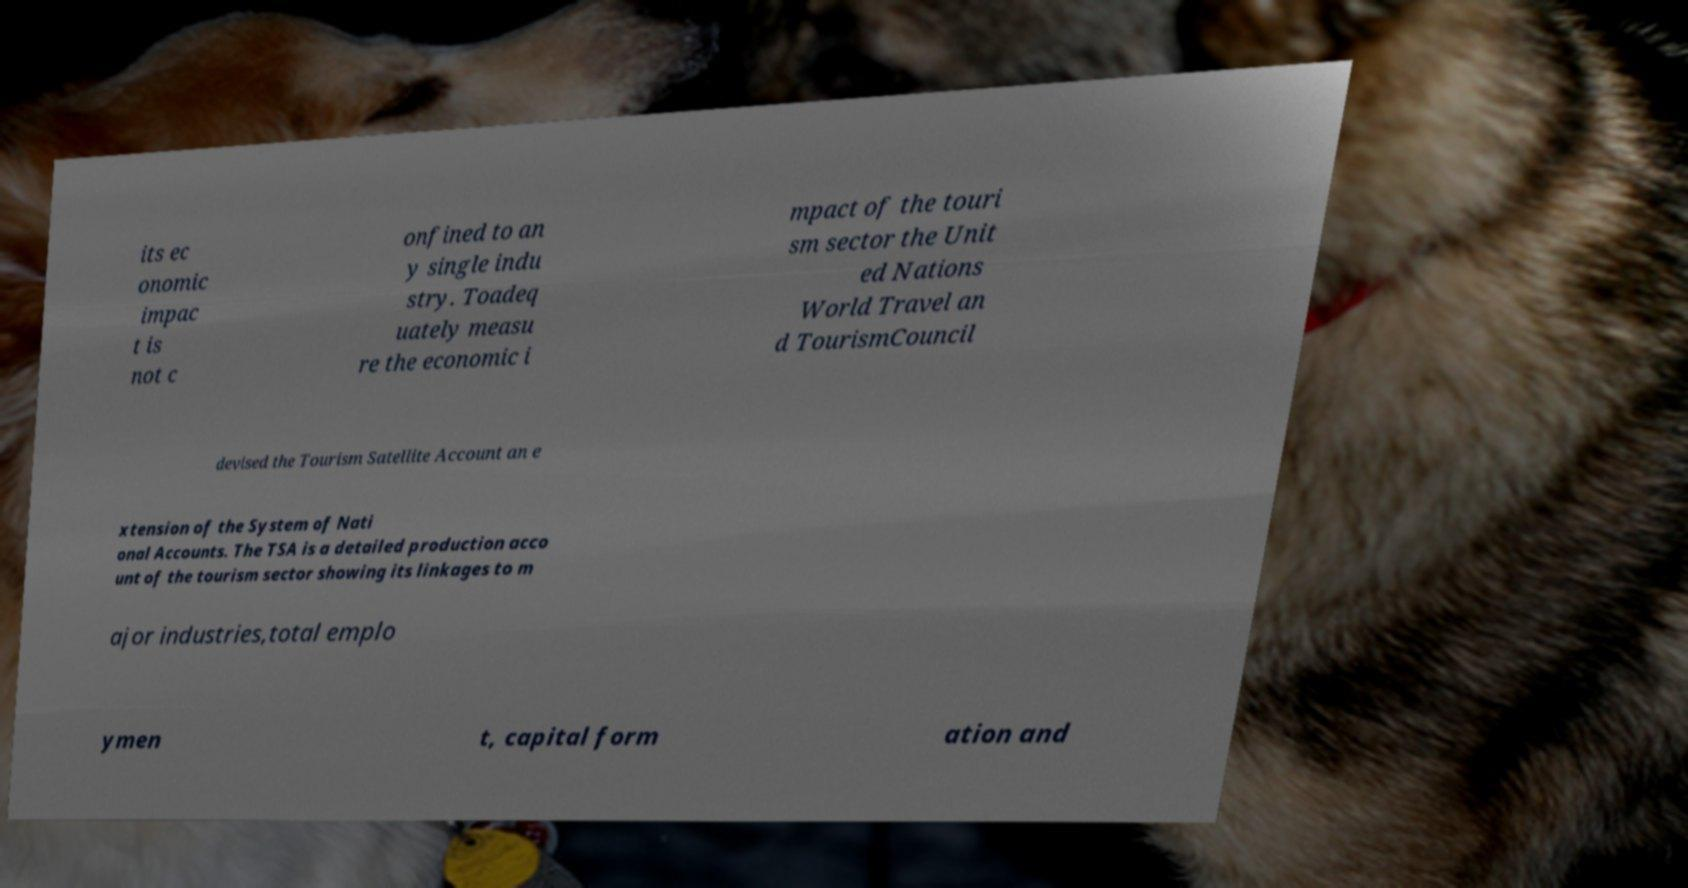I need the written content from this picture converted into text. Can you do that? its ec onomic impac t is not c onfined to an y single indu stry. Toadeq uately measu re the economic i mpact of the touri sm sector the Unit ed Nations World Travel an d TourismCouncil devised the Tourism Satellite Account an e xtension of the System of Nati onal Accounts. The TSA is a detailed production acco unt of the tourism sector showing its linkages to m ajor industries,total emplo ymen t, capital form ation and 